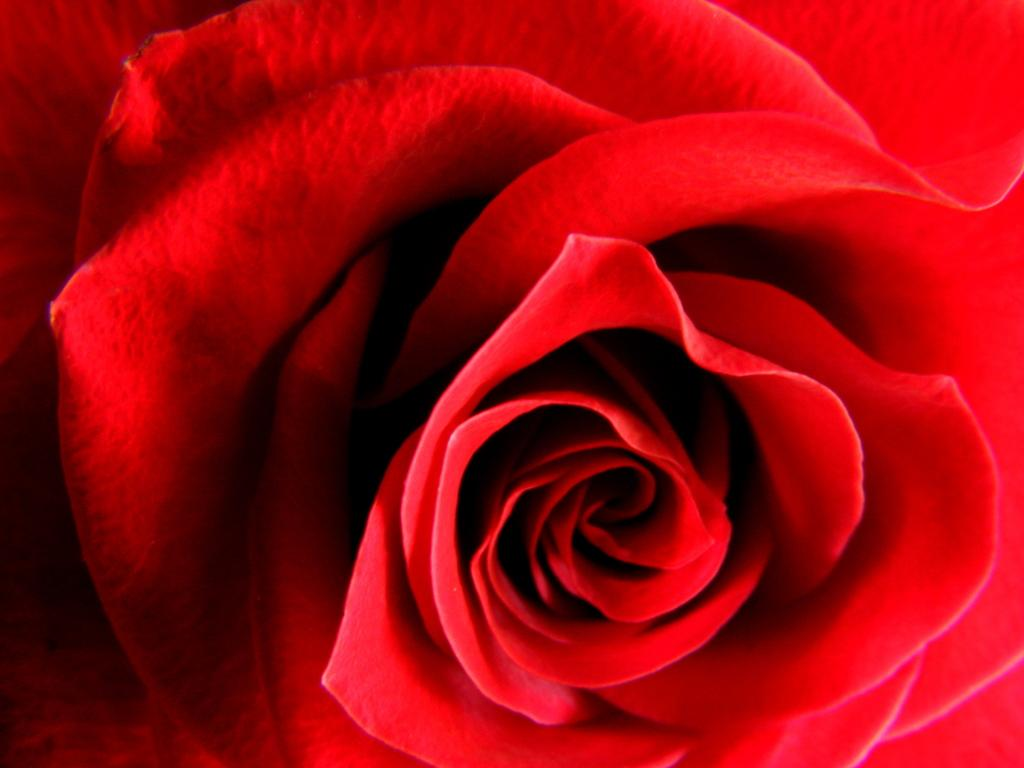What type of flower is in the image? There is a red color rose flower in the image. What part of the flower is visible in the image? The petals of the flower are visible in the image. How many leaves can be seen on the rose flower in the image? There is no mention of leaves on the rose flower in the image; only the petals are visible. 